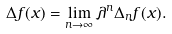Convert formula to latex. <formula><loc_0><loc_0><loc_500><loc_500>\Delta f ( x ) = \lim _ { n \to \infty } \lambda ^ { n } \Delta _ { n } f ( x ) .</formula> 